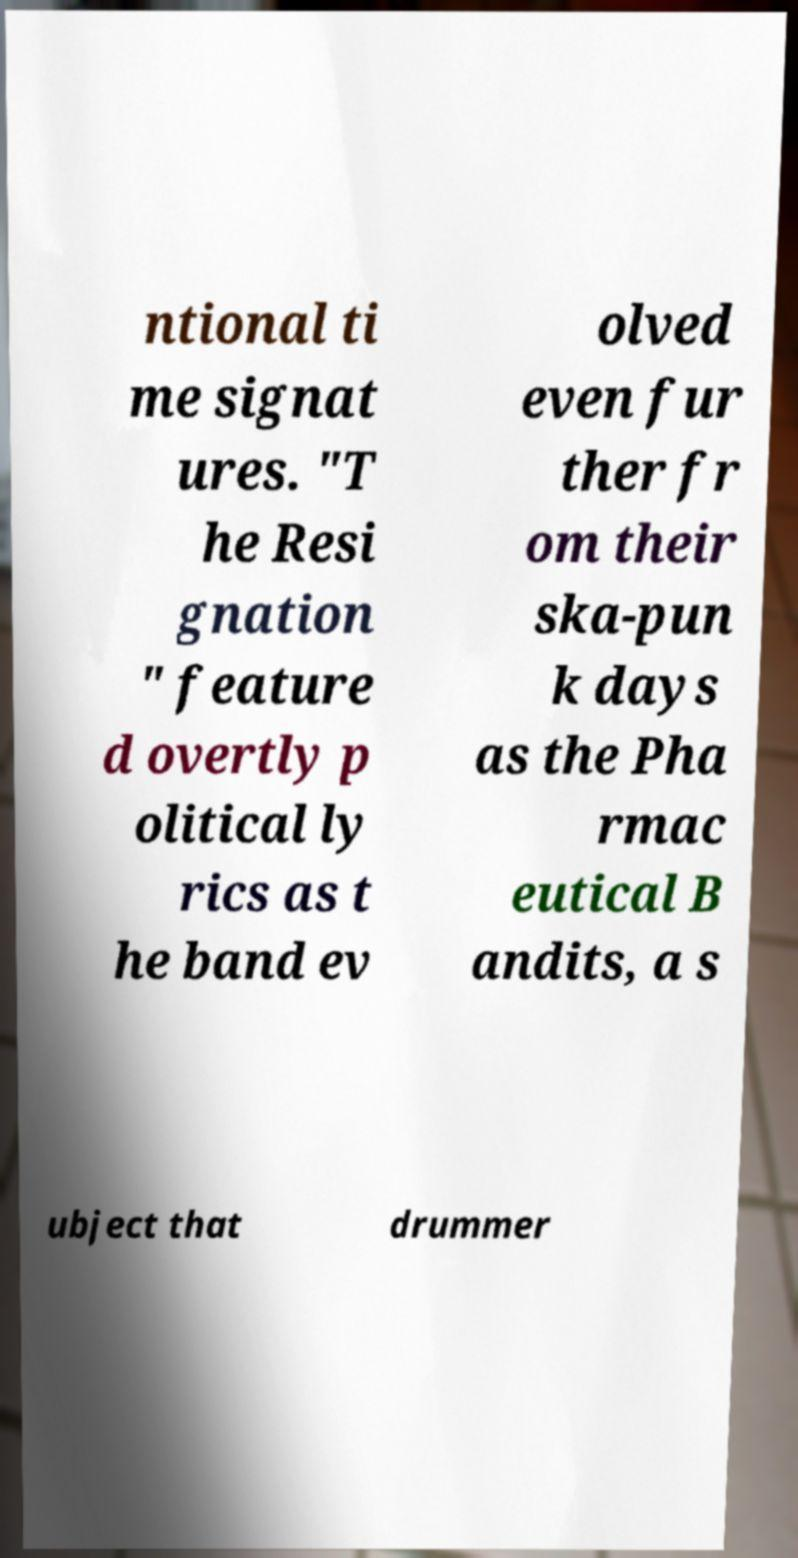I need the written content from this picture converted into text. Can you do that? ntional ti me signat ures. "T he Resi gnation " feature d overtly p olitical ly rics as t he band ev olved even fur ther fr om their ska-pun k days as the Pha rmac eutical B andits, a s ubject that drummer 